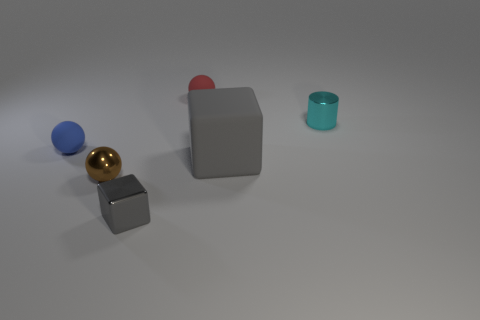Are the big gray thing and the ball behind the cyan thing made of the same material?
Offer a very short reply. Yes. What number of things are small purple cubes or tiny matte objects?
Your answer should be very brief. 2. Is there a small red matte thing?
Your answer should be very brief. Yes. There is a metal thing behind the matte ball that is in front of the red matte ball; what shape is it?
Your answer should be compact. Cylinder. What number of objects are things in front of the brown shiny ball or blocks that are on the left side of the big gray thing?
Your answer should be very brief. 1. What is the material of the cyan object that is the same size as the red matte thing?
Make the answer very short. Metal. What is the color of the matte cube?
Your answer should be very brief. Gray. There is a ball that is to the right of the blue rubber sphere and behind the small shiny ball; what is its material?
Provide a succinct answer. Rubber. Are there any small gray blocks that are behind the tiny metal thing that is right of the gray object that is right of the tiny block?
Your response must be concise. No. There is a matte block that is the same color as the metal cube; what is its size?
Ensure brevity in your answer.  Large. 